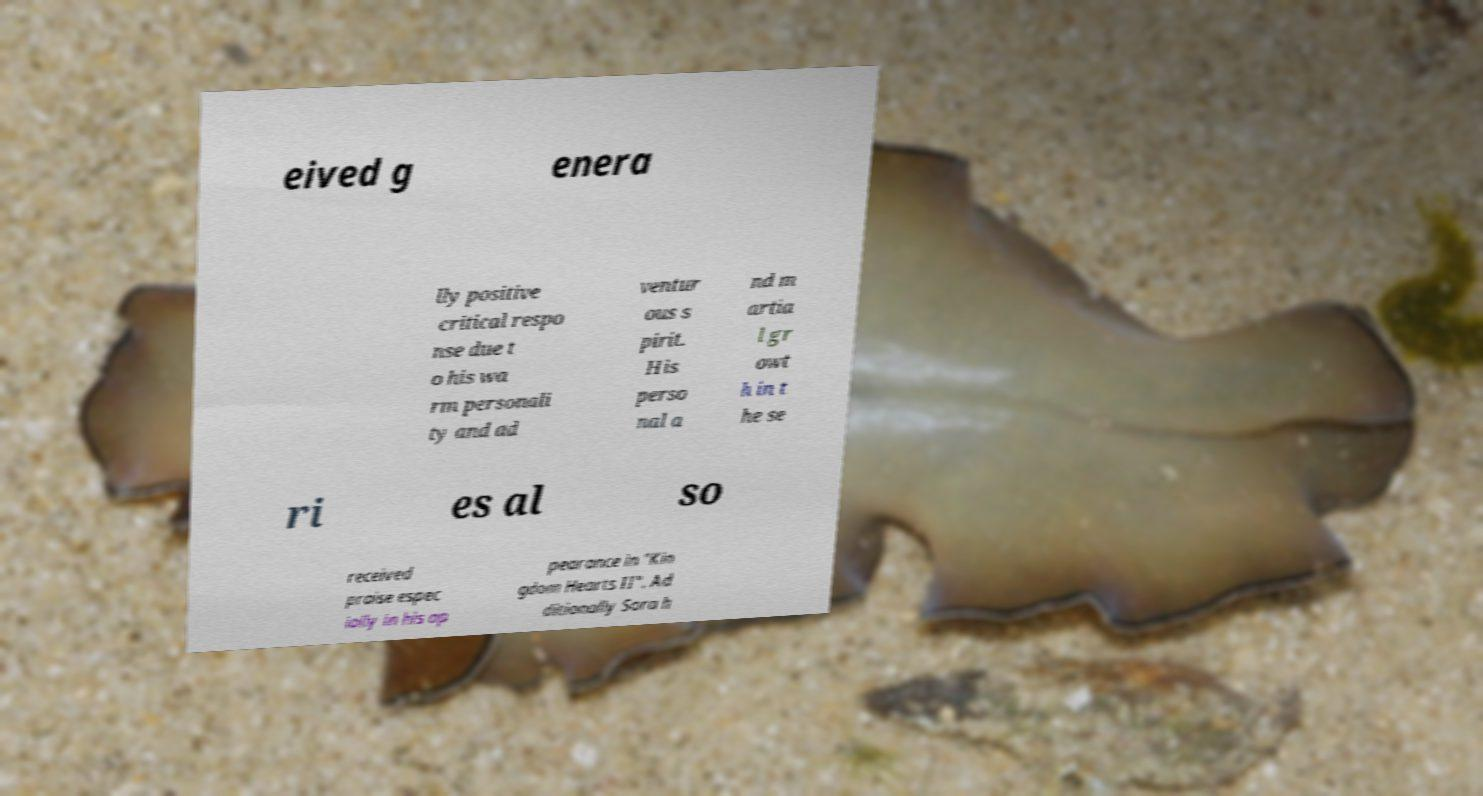Could you assist in decoding the text presented in this image and type it out clearly? eived g enera lly positive critical respo nse due t o his wa rm personali ty and ad ventur ous s pirit. His perso nal a nd m artia l gr owt h in t he se ri es al so received praise espec ially in his ap pearance in "Kin gdom Hearts II". Ad ditionally Sora h 